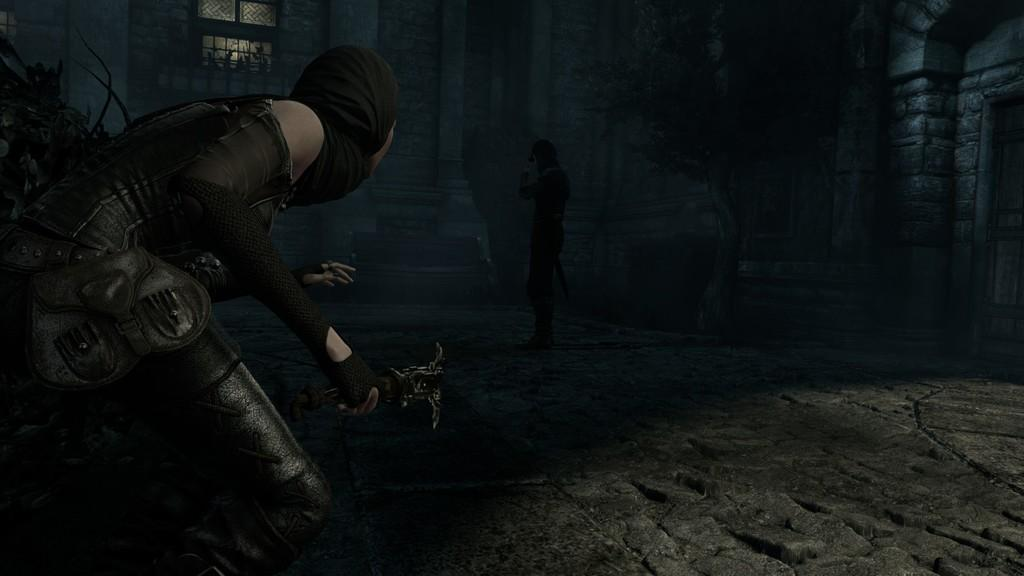How many people are in the image? There are two people in the image. What are the two people holding? The two people are holding something. What type of structure is visible in the image? There is a building in the image. Is there any opening in the building visible in the image? Yes, there is a window in the image. How would you describe the lighting in the image? The image is dark. Is there a lock visible in the image? There is no lock present in the image. Can you see any quicksand in the image? There is no quicksand present in the image. 